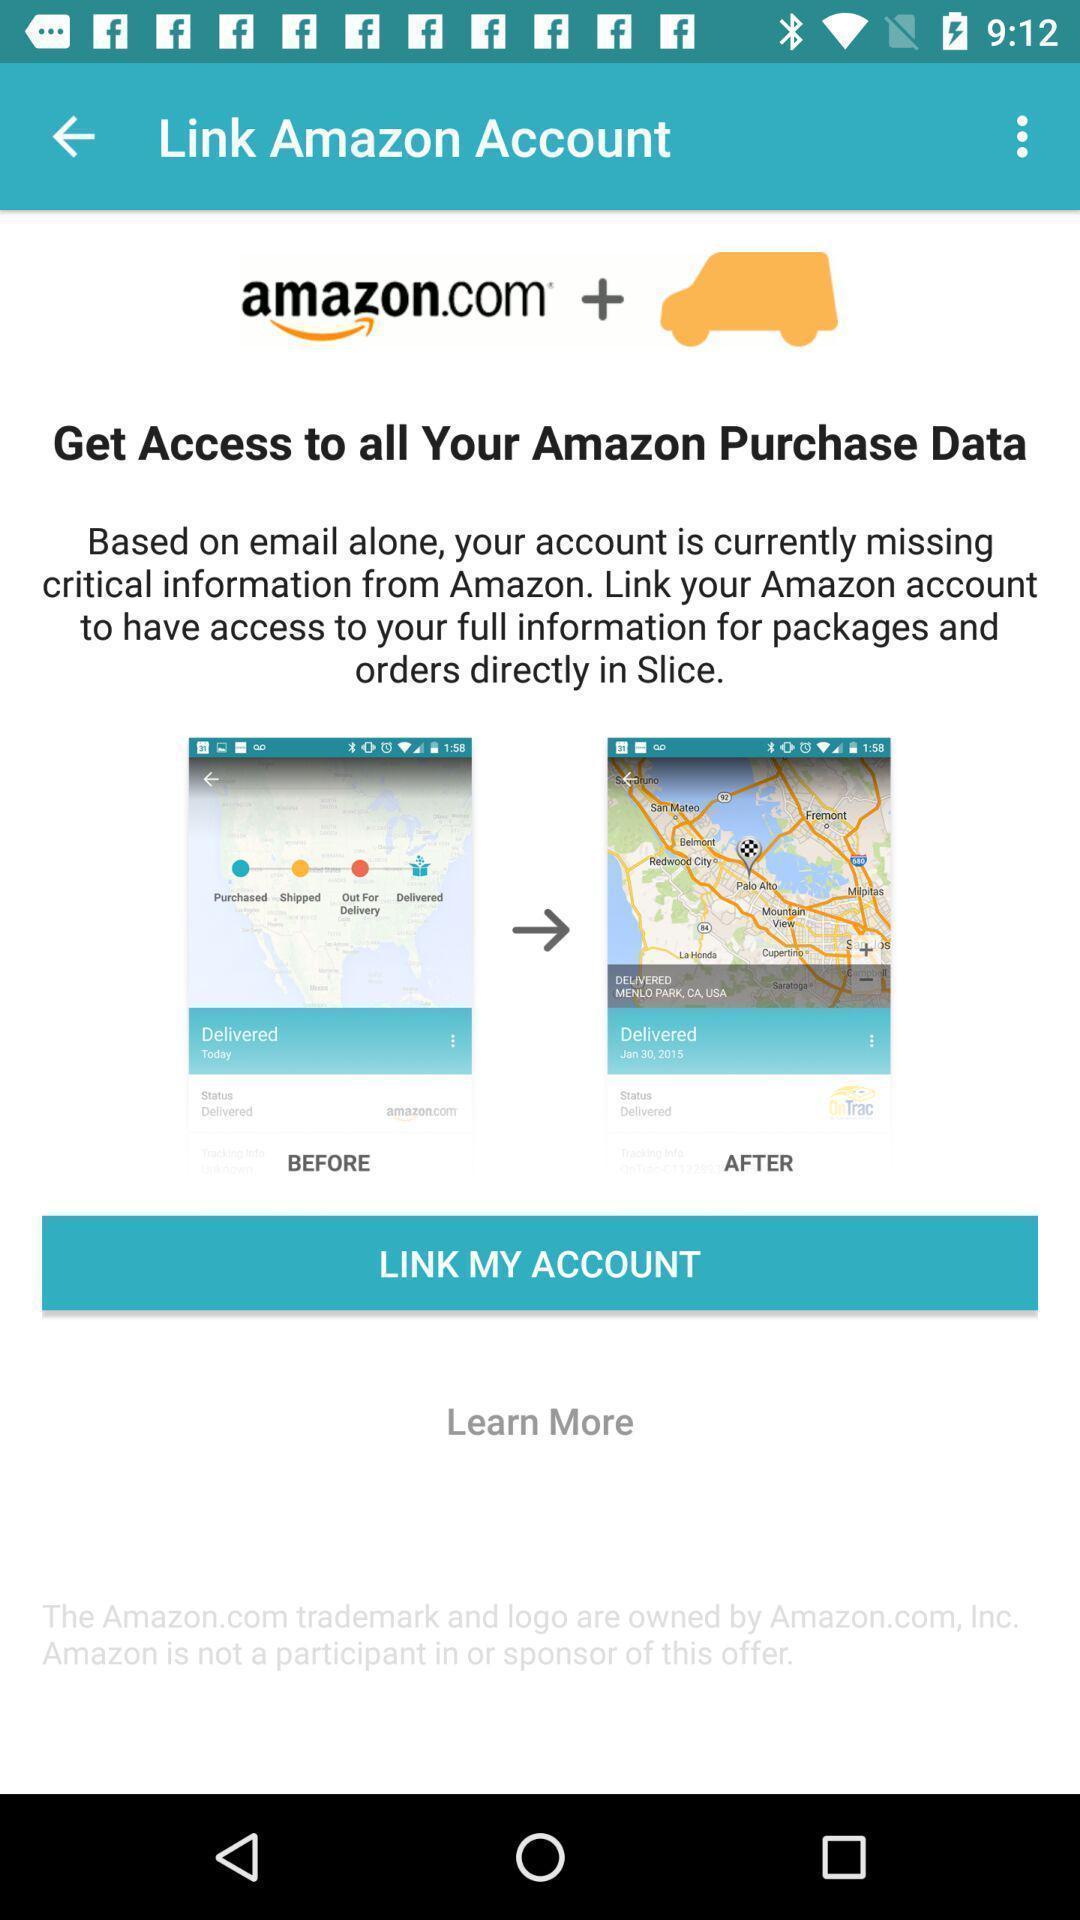Give me a narrative description of this picture. Page for linking an account. 